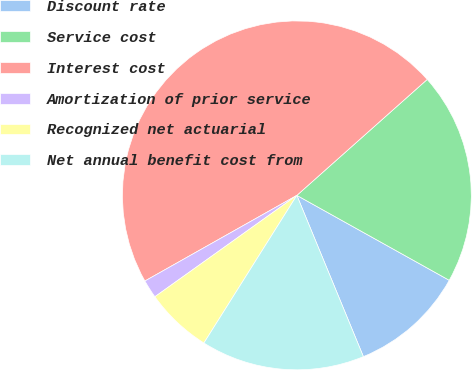<chart> <loc_0><loc_0><loc_500><loc_500><pie_chart><fcel>Discount rate<fcel>Service cost<fcel>Interest cost<fcel>Amortization of prior service<fcel>Recognized net actuarial<fcel>Net annual benefit cost from<nl><fcel>10.68%<fcel>19.66%<fcel>46.6%<fcel>1.7%<fcel>6.19%<fcel>15.17%<nl></chart> 